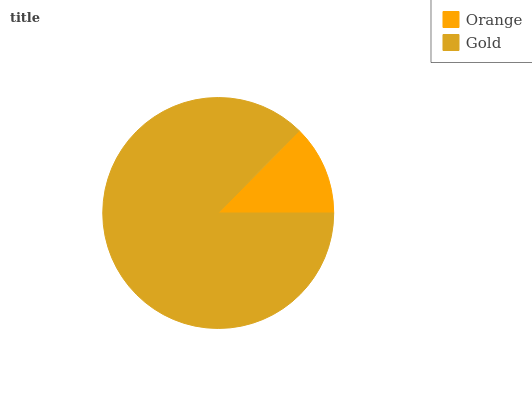Is Orange the minimum?
Answer yes or no. Yes. Is Gold the maximum?
Answer yes or no. Yes. Is Gold the minimum?
Answer yes or no. No. Is Gold greater than Orange?
Answer yes or no. Yes. Is Orange less than Gold?
Answer yes or no. Yes. Is Orange greater than Gold?
Answer yes or no. No. Is Gold less than Orange?
Answer yes or no. No. Is Gold the high median?
Answer yes or no. Yes. Is Orange the low median?
Answer yes or no. Yes. Is Orange the high median?
Answer yes or no. No. Is Gold the low median?
Answer yes or no. No. 